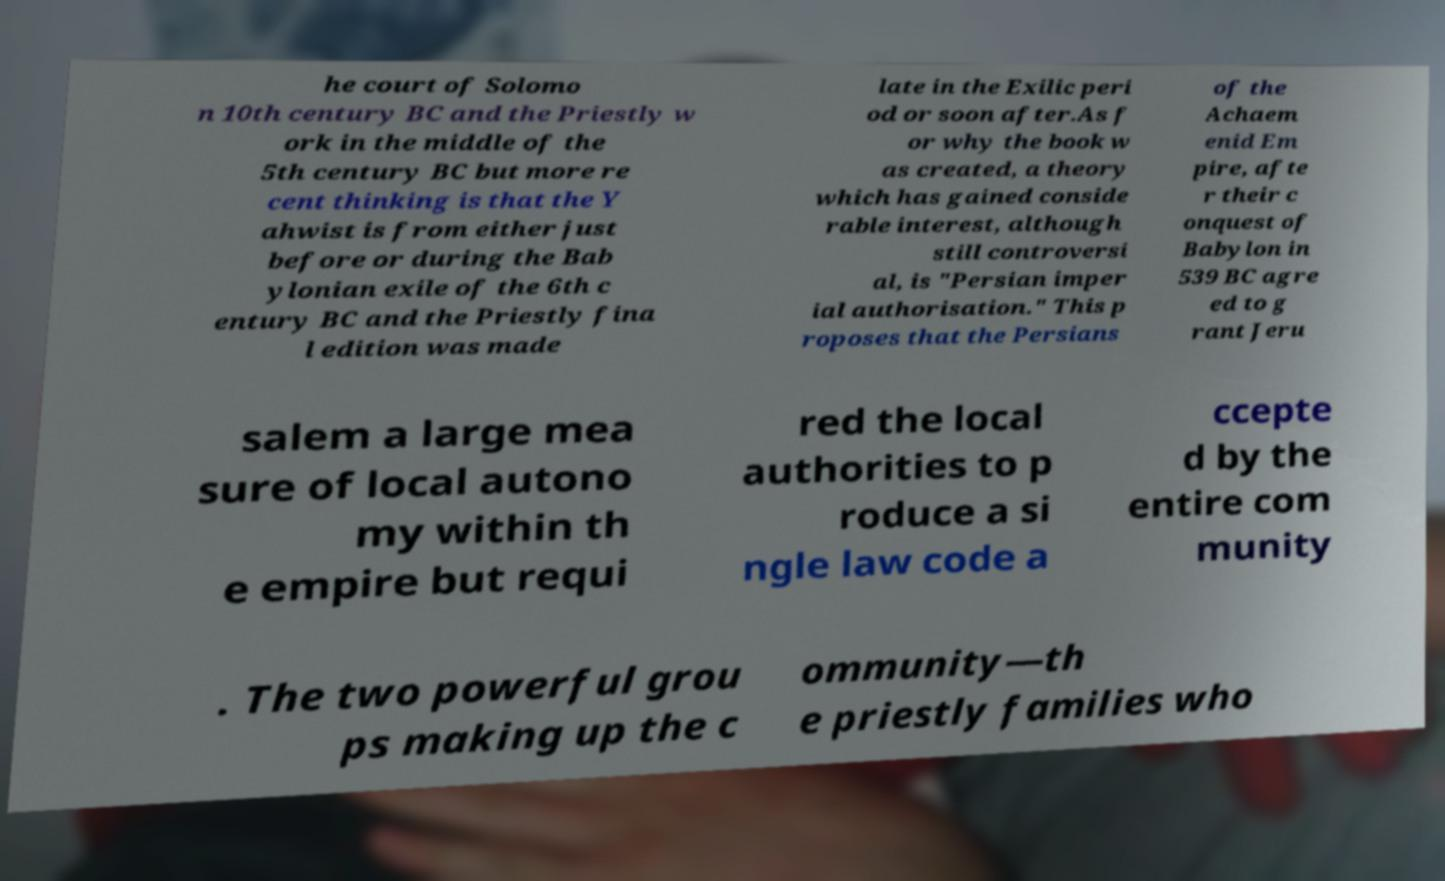Please read and relay the text visible in this image. What does it say? he court of Solomo n 10th century BC and the Priestly w ork in the middle of the 5th century BC but more re cent thinking is that the Y ahwist is from either just before or during the Bab ylonian exile of the 6th c entury BC and the Priestly fina l edition was made late in the Exilic peri od or soon after.As f or why the book w as created, a theory which has gained conside rable interest, although still controversi al, is "Persian imper ial authorisation." This p roposes that the Persians of the Achaem enid Em pire, afte r their c onquest of Babylon in 539 BC agre ed to g rant Jeru salem a large mea sure of local autono my within th e empire but requi red the local authorities to p roduce a si ngle law code a ccepte d by the entire com munity . The two powerful grou ps making up the c ommunity—th e priestly families who 